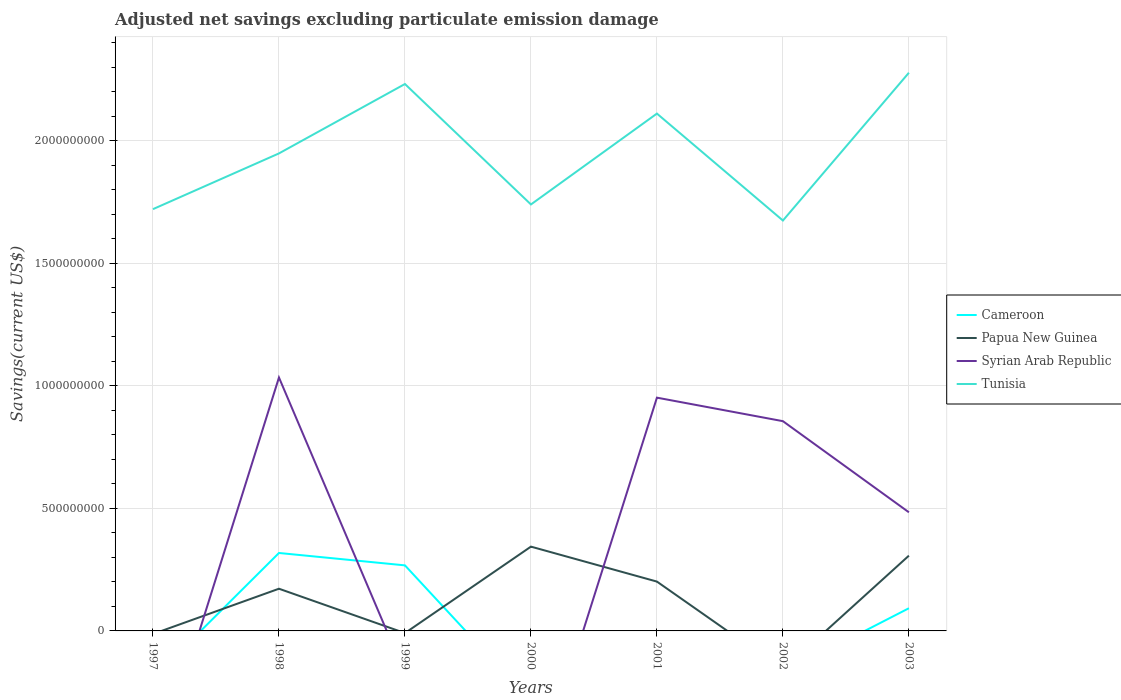Across all years, what is the maximum adjusted net savings in Syrian Arab Republic?
Ensure brevity in your answer.  0. What is the total adjusted net savings in Papua New Guinea in the graph?
Ensure brevity in your answer.  -1.35e+08. What is the difference between the highest and the second highest adjusted net savings in Syrian Arab Republic?
Your answer should be very brief. 1.03e+09. How many lines are there?
Your answer should be compact. 4. Where does the legend appear in the graph?
Offer a terse response. Center right. How are the legend labels stacked?
Offer a terse response. Vertical. What is the title of the graph?
Make the answer very short. Adjusted net savings excluding particulate emission damage. Does "Peru" appear as one of the legend labels in the graph?
Your response must be concise. No. What is the label or title of the Y-axis?
Ensure brevity in your answer.  Savings(current US$). What is the Savings(current US$) of Cameroon in 1997?
Your answer should be compact. 0. What is the Savings(current US$) in Syrian Arab Republic in 1997?
Provide a short and direct response. 0. What is the Savings(current US$) of Tunisia in 1997?
Make the answer very short. 1.72e+09. What is the Savings(current US$) in Cameroon in 1998?
Ensure brevity in your answer.  3.18e+08. What is the Savings(current US$) of Papua New Guinea in 1998?
Give a very brief answer. 1.72e+08. What is the Savings(current US$) in Syrian Arab Republic in 1998?
Offer a terse response. 1.03e+09. What is the Savings(current US$) in Tunisia in 1998?
Offer a terse response. 1.95e+09. What is the Savings(current US$) of Cameroon in 1999?
Your response must be concise. 2.67e+08. What is the Savings(current US$) in Papua New Guinea in 1999?
Offer a very short reply. 0. What is the Savings(current US$) in Syrian Arab Republic in 1999?
Your answer should be very brief. 0. What is the Savings(current US$) of Tunisia in 1999?
Give a very brief answer. 2.23e+09. What is the Savings(current US$) of Papua New Guinea in 2000?
Ensure brevity in your answer.  3.44e+08. What is the Savings(current US$) in Syrian Arab Republic in 2000?
Keep it short and to the point. 0. What is the Savings(current US$) of Tunisia in 2000?
Offer a terse response. 1.74e+09. What is the Savings(current US$) of Papua New Guinea in 2001?
Ensure brevity in your answer.  2.01e+08. What is the Savings(current US$) in Syrian Arab Republic in 2001?
Provide a succinct answer. 9.51e+08. What is the Savings(current US$) of Tunisia in 2001?
Offer a very short reply. 2.11e+09. What is the Savings(current US$) in Cameroon in 2002?
Keep it short and to the point. 0. What is the Savings(current US$) of Papua New Guinea in 2002?
Your answer should be compact. 0. What is the Savings(current US$) of Syrian Arab Republic in 2002?
Keep it short and to the point. 8.56e+08. What is the Savings(current US$) in Tunisia in 2002?
Offer a terse response. 1.67e+09. What is the Savings(current US$) in Cameroon in 2003?
Offer a very short reply. 9.25e+07. What is the Savings(current US$) of Papua New Guinea in 2003?
Offer a very short reply. 3.07e+08. What is the Savings(current US$) in Syrian Arab Republic in 2003?
Provide a short and direct response. 4.84e+08. What is the Savings(current US$) in Tunisia in 2003?
Make the answer very short. 2.28e+09. Across all years, what is the maximum Savings(current US$) of Cameroon?
Make the answer very short. 3.18e+08. Across all years, what is the maximum Savings(current US$) in Papua New Guinea?
Make the answer very short. 3.44e+08. Across all years, what is the maximum Savings(current US$) in Syrian Arab Republic?
Provide a succinct answer. 1.03e+09. Across all years, what is the maximum Savings(current US$) of Tunisia?
Your response must be concise. 2.28e+09. Across all years, what is the minimum Savings(current US$) of Cameroon?
Your answer should be very brief. 0. Across all years, what is the minimum Savings(current US$) in Papua New Guinea?
Your answer should be compact. 0. Across all years, what is the minimum Savings(current US$) in Tunisia?
Your response must be concise. 1.67e+09. What is the total Savings(current US$) of Cameroon in the graph?
Provide a short and direct response. 6.78e+08. What is the total Savings(current US$) of Papua New Guinea in the graph?
Give a very brief answer. 1.02e+09. What is the total Savings(current US$) in Syrian Arab Republic in the graph?
Your answer should be very brief. 3.32e+09. What is the total Savings(current US$) of Tunisia in the graph?
Give a very brief answer. 1.37e+1. What is the difference between the Savings(current US$) in Tunisia in 1997 and that in 1998?
Give a very brief answer. -2.27e+08. What is the difference between the Savings(current US$) in Tunisia in 1997 and that in 1999?
Your answer should be very brief. -5.10e+08. What is the difference between the Savings(current US$) of Tunisia in 1997 and that in 2000?
Give a very brief answer. -1.92e+07. What is the difference between the Savings(current US$) of Tunisia in 1997 and that in 2001?
Ensure brevity in your answer.  -3.90e+08. What is the difference between the Savings(current US$) of Tunisia in 1997 and that in 2002?
Provide a short and direct response. 4.64e+07. What is the difference between the Savings(current US$) in Tunisia in 1997 and that in 2003?
Keep it short and to the point. -5.56e+08. What is the difference between the Savings(current US$) in Cameroon in 1998 and that in 1999?
Provide a short and direct response. 5.05e+07. What is the difference between the Savings(current US$) in Tunisia in 1998 and that in 1999?
Provide a succinct answer. -2.83e+08. What is the difference between the Savings(current US$) in Papua New Guinea in 1998 and that in 2000?
Offer a terse response. -1.72e+08. What is the difference between the Savings(current US$) in Tunisia in 1998 and that in 2000?
Your answer should be compact. 2.08e+08. What is the difference between the Savings(current US$) in Papua New Guinea in 1998 and that in 2001?
Your response must be concise. -2.91e+07. What is the difference between the Savings(current US$) in Syrian Arab Republic in 1998 and that in 2001?
Offer a very short reply. 8.22e+07. What is the difference between the Savings(current US$) in Tunisia in 1998 and that in 2001?
Ensure brevity in your answer.  -1.62e+08. What is the difference between the Savings(current US$) in Syrian Arab Republic in 1998 and that in 2002?
Offer a terse response. 1.78e+08. What is the difference between the Savings(current US$) in Tunisia in 1998 and that in 2002?
Provide a succinct answer. 2.74e+08. What is the difference between the Savings(current US$) of Cameroon in 1998 and that in 2003?
Make the answer very short. 2.25e+08. What is the difference between the Savings(current US$) in Papua New Guinea in 1998 and that in 2003?
Ensure brevity in your answer.  -1.35e+08. What is the difference between the Savings(current US$) in Syrian Arab Republic in 1998 and that in 2003?
Your answer should be compact. 5.50e+08. What is the difference between the Savings(current US$) in Tunisia in 1998 and that in 2003?
Offer a terse response. -3.29e+08. What is the difference between the Savings(current US$) of Tunisia in 1999 and that in 2000?
Your answer should be very brief. 4.91e+08. What is the difference between the Savings(current US$) in Tunisia in 1999 and that in 2001?
Your answer should be very brief. 1.21e+08. What is the difference between the Savings(current US$) of Tunisia in 1999 and that in 2002?
Offer a terse response. 5.57e+08. What is the difference between the Savings(current US$) of Cameroon in 1999 and that in 2003?
Offer a very short reply. 1.75e+08. What is the difference between the Savings(current US$) in Tunisia in 1999 and that in 2003?
Provide a succinct answer. -4.60e+07. What is the difference between the Savings(current US$) of Papua New Guinea in 2000 and that in 2001?
Offer a terse response. 1.43e+08. What is the difference between the Savings(current US$) of Tunisia in 2000 and that in 2001?
Provide a short and direct response. -3.71e+08. What is the difference between the Savings(current US$) in Tunisia in 2000 and that in 2002?
Offer a very short reply. 6.55e+07. What is the difference between the Savings(current US$) in Papua New Guinea in 2000 and that in 2003?
Give a very brief answer. 3.68e+07. What is the difference between the Savings(current US$) in Tunisia in 2000 and that in 2003?
Provide a succinct answer. -5.37e+08. What is the difference between the Savings(current US$) in Syrian Arab Republic in 2001 and that in 2002?
Your answer should be compact. 9.59e+07. What is the difference between the Savings(current US$) in Tunisia in 2001 and that in 2002?
Offer a terse response. 4.36e+08. What is the difference between the Savings(current US$) of Papua New Guinea in 2001 and that in 2003?
Your response must be concise. -1.06e+08. What is the difference between the Savings(current US$) of Syrian Arab Republic in 2001 and that in 2003?
Make the answer very short. 4.68e+08. What is the difference between the Savings(current US$) of Tunisia in 2001 and that in 2003?
Give a very brief answer. -1.67e+08. What is the difference between the Savings(current US$) of Syrian Arab Republic in 2002 and that in 2003?
Offer a very short reply. 3.72e+08. What is the difference between the Savings(current US$) of Tunisia in 2002 and that in 2003?
Ensure brevity in your answer.  -6.03e+08. What is the difference between the Savings(current US$) of Cameroon in 1998 and the Savings(current US$) of Tunisia in 1999?
Your answer should be very brief. -1.91e+09. What is the difference between the Savings(current US$) in Papua New Guinea in 1998 and the Savings(current US$) in Tunisia in 1999?
Give a very brief answer. -2.06e+09. What is the difference between the Savings(current US$) of Syrian Arab Republic in 1998 and the Savings(current US$) of Tunisia in 1999?
Keep it short and to the point. -1.20e+09. What is the difference between the Savings(current US$) in Cameroon in 1998 and the Savings(current US$) in Papua New Guinea in 2000?
Your response must be concise. -2.59e+07. What is the difference between the Savings(current US$) of Cameroon in 1998 and the Savings(current US$) of Tunisia in 2000?
Provide a short and direct response. -1.42e+09. What is the difference between the Savings(current US$) in Papua New Guinea in 1998 and the Savings(current US$) in Tunisia in 2000?
Make the answer very short. -1.57e+09. What is the difference between the Savings(current US$) in Syrian Arab Republic in 1998 and the Savings(current US$) in Tunisia in 2000?
Provide a short and direct response. -7.06e+08. What is the difference between the Savings(current US$) in Cameroon in 1998 and the Savings(current US$) in Papua New Guinea in 2001?
Keep it short and to the point. 1.17e+08. What is the difference between the Savings(current US$) of Cameroon in 1998 and the Savings(current US$) of Syrian Arab Republic in 2001?
Make the answer very short. -6.34e+08. What is the difference between the Savings(current US$) in Cameroon in 1998 and the Savings(current US$) in Tunisia in 2001?
Provide a succinct answer. -1.79e+09. What is the difference between the Savings(current US$) in Papua New Guinea in 1998 and the Savings(current US$) in Syrian Arab Republic in 2001?
Your answer should be very brief. -7.79e+08. What is the difference between the Savings(current US$) of Papua New Guinea in 1998 and the Savings(current US$) of Tunisia in 2001?
Your answer should be very brief. -1.94e+09. What is the difference between the Savings(current US$) of Syrian Arab Republic in 1998 and the Savings(current US$) of Tunisia in 2001?
Your answer should be very brief. -1.08e+09. What is the difference between the Savings(current US$) of Cameroon in 1998 and the Savings(current US$) of Syrian Arab Republic in 2002?
Provide a short and direct response. -5.38e+08. What is the difference between the Savings(current US$) of Cameroon in 1998 and the Savings(current US$) of Tunisia in 2002?
Offer a terse response. -1.36e+09. What is the difference between the Savings(current US$) of Papua New Guinea in 1998 and the Savings(current US$) of Syrian Arab Republic in 2002?
Ensure brevity in your answer.  -6.83e+08. What is the difference between the Savings(current US$) in Papua New Guinea in 1998 and the Savings(current US$) in Tunisia in 2002?
Offer a very short reply. -1.50e+09. What is the difference between the Savings(current US$) of Syrian Arab Republic in 1998 and the Savings(current US$) of Tunisia in 2002?
Your response must be concise. -6.40e+08. What is the difference between the Savings(current US$) of Cameroon in 1998 and the Savings(current US$) of Papua New Guinea in 2003?
Provide a short and direct response. 1.09e+07. What is the difference between the Savings(current US$) in Cameroon in 1998 and the Savings(current US$) in Syrian Arab Republic in 2003?
Ensure brevity in your answer.  -1.66e+08. What is the difference between the Savings(current US$) of Cameroon in 1998 and the Savings(current US$) of Tunisia in 2003?
Offer a very short reply. -1.96e+09. What is the difference between the Savings(current US$) in Papua New Guinea in 1998 and the Savings(current US$) in Syrian Arab Republic in 2003?
Keep it short and to the point. -3.12e+08. What is the difference between the Savings(current US$) in Papua New Guinea in 1998 and the Savings(current US$) in Tunisia in 2003?
Offer a very short reply. -2.10e+09. What is the difference between the Savings(current US$) in Syrian Arab Republic in 1998 and the Savings(current US$) in Tunisia in 2003?
Provide a succinct answer. -1.24e+09. What is the difference between the Savings(current US$) in Cameroon in 1999 and the Savings(current US$) in Papua New Guinea in 2000?
Make the answer very short. -7.64e+07. What is the difference between the Savings(current US$) in Cameroon in 1999 and the Savings(current US$) in Tunisia in 2000?
Give a very brief answer. -1.47e+09. What is the difference between the Savings(current US$) of Cameroon in 1999 and the Savings(current US$) of Papua New Guinea in 2001?
Your answer should be compact. 6.62e+07. What is the difference between the Savings(current US$) of Cameroon in 1999 and the Savings(current US$) of Syrian Arab Republic in 2001?
Provide a succinct answer. -6.84e+08. What is the difference between the Savings(current US$) in Cameroon in 1999 and the Savings(current US$) in Tunisia in 2001?
Keep it short and to the point. -1.84e+09. What is the difference between the Savings(current US$) of Cameroon in 1999 and the Savings(current US$) of Syrian Arab Republic in 2002?
Make the answer very short. -5.88e+08. What is the difference between the Savings(current US$) of Cameroon in 1999 and the Savings(current US$) of Tunisia in 2002?
Provide a succinct answer. -1.41e+09. What is the difference between the Savings(current US$) of Cameroon in 1999 and the Savings(current US$) of Papua New Guinea in 2003?
Provide a short and direct response. -3.96e+07. What is the difference between the Savings(current US$) of Cameroon in 1999 and the Savings(current US$) of Syrian Arab Republic in 2003?
Make the answer very short. -2.16e+08. What is the difference between the Savings(current US$) in Cameroon in 1999 and the Savings(current US$) in Tunisia in 2003?
Your answer should be very brief. -2.01e+09. What is the difference between the Savings(current US$) in Papua New Guinea in 2000 and the Savings(current US$) in Syrian Arab Republic in 2001?
Keep it short and to the point. -6.08e+08. What is the difference between the Savings(current US$) of Papua New Guinea in 2000 and the Savings(current US$) of Tunisia in 2001?
Ensure brevity in your answer.  -1.77e+09. What is the difference between the Savings(current US$) of Papua New Guinea in 2000 and the Savings(current US$) of Syrian Arab Republic in 2002?
Provide a short and direct response. -5.12e+08. What is the difference between the Savings(current US$) in Papua New Guinea in 2000 and the Savings(current US$) in Tunisia in 2002?
Make the answer very short. -1.33e+09. What is the difference between the Savings(current US$) in Papua New Guinea in 2000 and the Savings(current US$) in Syrian Arab Republic in 2003?
Your answer should be compact. -1.40e+08. What is the difference between the Savings(current US$) of Papua New Guinea in 2000 and the Savings(current US$) of Tunisia in 2003?
Keep it short and to the point. -1.93e+09. What is the difference between the Savings(current US$) in Papua New Guinea in 2001 and the Savings(current US$) in Syrian Arab Republic in 2002?
Keep it short and to the point. -6.54e+08. What is the difference between the Savings(current US$) of Papua New Guinea in 2001 and the Savings(current US$) of Tunisia in 2002?
Provide a short and direct response. -1.47e+09. What is the difference between the Savings(current US$) in Syrian Arab Republic in 2001 and the Savings(current US$) in Tunisia in 2002?
Keep it short and to the point. -7.23e+08. What is the difference between the Savings(current US$) of Papua New Guinea in 2001 and the Savings(current US$) of Syrian Arab Republic in 2003?
Your answer should be compact. -2.83e+08. What is the difference between the Savings(current US$) in Papua New Guinea in 2001 and the Savings(current US$) in Tunisia in 2003?
Your response must be concise. -2.08e+09. What is the difference between the Savings(current US$) in Syrian Arab Republic in 2001 and the Savings(current US$) in Tunisia in 2003?
Make the answer very short. -1.33e+09. What is the difference between the Savings(current US$) of Syrian Arab Republic in 2002 and the Savings(current US$) of Tunisia in 2003?
Provide a short and direct response. -1.42e+09. What is the average Savings(current US$) of Cameroon per year?
Provide a succinct answer. 9.68e+07. What is the average Savings(current US$) in Papua New Guinea per year?
Provide a succinct answer. 1.46e+08. What is the average Savings(current US$) in Syrian Arab Republic per year?
Your answer should be compact. 4.75e+08. What is the average Savings(current US$) in Tunisia per year?
Your response must be concise. 1.96e+09. In the year 1998, what is the difference between the Savings(current US$) in Cameroon and Savings(current US$) in Papua New Guinea?
Keep it short and to the point. 1.46e+08. In the year 1998, what is the difference between the Savings(current US$) of Cameroon and Savings(current US$) of Syrian Arab Republic?
Keep it short and to the point. -7.16e+08. In the year 1998, what is the difference between the Savings(current US$) of Cameroon and Savings(current US$) of Tunisia?
Provide a succinct answer. -1.63e+09. In the year 1998, what is the difference between the Savings(current US$) of Papua New Guinea and Savings(current US$) of Syrian Arab Republic?
Your answer should be compact. -8.62e+08. In the year 1998, what is the difference between the Savings(current US$) in Papua New Guinea and Savings(current US$) in Tunisia?
Provide a succinct answer. -1.78e+09. In the year 1998, what is the difference between the Savings(current US$) of Syrian Arab Republic and Savings(current US$) of Tunisia?
Offer a very short reply. -9.14e+08. In the year 1999, what is the difference between the Savings(current US$) of Cameroon and Savings(current US$) of Tunisia?
Your answer should be compact. -1.96e+09. In the year 2000, what is the difference between the Savings(current US$) of Papua New Guinea and Savings(current US$) of Tunisia?
Your response must be concise. -1.40e+09. In the year 2001, what is the difference between the Savings(current US$) in Papua New Guinea and Savings(current US$) in Syrian Arab Republic?
Keep it short and to the point. -7.50e+08. In the year 2001, what is the difference between the Savings(current US$) of Papua New Guinea and Savings(current US$) of Tunisia?
Ensure brevity in your answer.  -1.91e+09. In the year 2001, what is the difference between the Savings(current US$) in Syrian Arab Republic and Savings(current US$) in Tunisia?
Keep it short and to the point. -1.16e+09. In the year 2002, what is the difference between the Savings(current US$) in Syrian Arab Republic and Savings(current US$) in Tunisia?
Keep it short and to the point. -8.18e+08. In the year 2003, what is the difference between the Savings(current US$) in Cameroon and Savings(current US$) in Papua New Guinea?
Provide a short and direct response. -2.14e+08. In the year 2003, what is the difference between the Savings(current US$) in Cameroon and Savings(current US$) in Syrian Arab Republic?
Ensure brevity in your answer.  -3.91e+08. In the year 2003, what is the difference between the Savings(current US$) in Cameroon and Savings(current US$) in Tunisia?
Provide a short and direct response. -2.18e+09. In the year 2003, what is the difference between the Savings(current US$) in Papua New Guinea and Savings(current US$) in Syrian Arab Republic?
Ensure brevity in your answer.  -1.77e+08. In the year 2003, what is the difference between the Savings(current US$) of Papua New Guinea and Savings(current US$) of Tunisia?
Provide a succinct answer. -1.97e+09. In the year 2003, what is the difference between the Savings(current US$) in Syrian Arab Republic and Savings(current US$) in Tunisia?
Your response must be concise. -1.79e+09. What is the ratio of the Savings(current US$) in Tunisia in 1997 to that in 1998?
Your answer should be compact. 0.88. What is the ratio of the Savings(current US$) in Tunisia in 1997 to that in 1999?
Keep it short and to the point. 0.77. What is the ratio of the Savings(current US$) in Tunisia in 1997 to that in 2000?
Provide a succinct answer. 0.99. What is the ratio of the Savings(current US$) in Tunisia in 1997 to that in 2001?
Ensure brevity in your answer.  0.82. What is the ratio of the Savings(current US$) in Tunisia in 1997 to that in 2002?
Keep it short and to the point. 1.03. What is the ratio of the Savings(current US$) of Tunisia in 1997 to that in 2003?
Keep it short and to the point. 0.76. What is the ratio of the Savings(current US$) of Cameroon in 1998 to that in 1999?
Keep it short and to the point. 1.19. What is the ratio of the Savings(current US$) of Tunisia in 1998 to that in 1999?
Ensure brevity in your answer.  0.87. What is the ratio of the Savings(current US$) in Papua New Guinea in 1998 to that in 2000?
Offer a terse response. 0.5. What is the ratio of the Savings(current US$) of Tunisia in 1998 to that in 2000?
Provide a succinct answer. 1.12. What is the ratio of the Savings(current US$) in Papua New Guinea in 1998 to that in 2001?
Give a very brief answer. 0.86. What is the ratio of the Savings(current US$) in Syrian Arab Republic in 1998 to that in 2001?
Offer a very short reply. 1.09. What is the ratio of the Savings(current US$) of Tunisia in 1998 to that in 2001?
Your answer should be very brief. 0.92. What is the ratio of the Savings(current US$) in Syrian Arab Republic in 1998 to that in 2002?
Your answer should be compact. 1.21. What is the ratio of the Savings(current US$) in Tunisia in 1998 to that in 2002?
Your answer should be compact. 1.16. What is the ratio of the Savings(current US$) of Cameroon in 1998 to that in 2003?
Your answer should be very brief. 3.44. What is the ratio of the Savings(current US$) of Papua New Guinea in 1998 to that in 2003?
Give a very brief answer. 0.56. What is the ratio of the Savings(current US$) in Syrian Arab Republic in 1998 to that in 2003?
Give a very brief answer. 2.14. What is the ratio of the Savings(current US$) of Tunisia in 1998 to that in 2003?
Offer a terse response. 0.86. What is the ratio of the Savings(current US$) in Tunisia in 1999 to that in 2000?
Keep it short and to the point. 1.28. What is the ratio of the Savings(current US$) in Tunisia in 1999 to that in 2001?
Provide a succinct answer. 1.06. What is the ratio of the Savings(current US$) of Tunisia in 1999 to that in 2002?
Offer a very short reply. 1.33. What is the ratio of the Savings(current US$) in Cameroon in 1999 to that in 2003?
Your answer should be very brief. 2.89. What is the ratio of the Savings(current US$) of Tunisia in 1999 to that in 2003?
Provide a succinct answer. 0.98. What is the ratio of the Savings(current US$) of Papua New Guinea in 2000 to that in 2001?
Ensure brevity in your answer.  1.71. What is the ratio of the Savings(current US$) in Tunisia in 2000 to that in 2001?
Keep it short and to the point. 0.82. What is the ratio of the Savings(current US$) in Tunisia in 2000 to that in 2002?
Your response must be concise. 1.04. What is the ratio of the Savings(current US$) in Papua New Guinea in 2000 to that in 2003?
Your answer should be very brief. 1.12. What is the ratio of the Savings(current US$) in Tunisia in 2000 to that in 2003?
Provide a short and direct response. 0.76. What is the ratio of the Savings(current US$) of Syrian Arab Republic in 2001 to that in 2002?
Provide a succinct answer. 1.11. What is the ratio of the Savings(current US$) of Tunisia in 2001 to that in 2002?
Your answer should be very brief. 1.26. What is the ratio of the Savings(current US$) in Papua New Guinea in 2001 to that in 2003?
Your response must be concise. 0.66. What is the ratio of the Savings(current US$) in Syrian Arab Republic in 2001 to that in 2003?
Offer a terse response. 1.97. What is the ratio of the Savings(current US$) in Tunisia in 2001 to that in 2003?
Your answer should be very brief. 0.93. What is the ratio of the Savings(current US$) of Syrian Arab Republic in 2002 to that in 2003?
Offer a terse response. 1.77. What is the ratio of the Savings(current US$) in Tunisia in 2002 to that in 2003?
Provide a short and direct response. 0.74. What is the difference between the highest and the second highest Savings(current US$) of Cameroon?
Give a very brief answer. 5.05e+07. What is the difference between the highest and the second highest Savings(current US$) of Papua New Guinea?
Ensure brevity in your answer.  3.68e+07. What is the difference between the highest and the second highest Savings(current US$) of Syrian Arab Republic?
Your answer should be compact. 8.22e+07. What is the difference between the highest and the second highest Savings(current US$) of Tunisia?
Your answer should be very brief. 4.60e+07. What is the difference between the highest and the lowest Savings(current US$) of Cameroon?
Ensure brevity in your answer.  3.18e+08. What is the difference between the highest and the lowest Savings(current US$) in Papua New Guinea?
Your answer should be very brief. 3.44e+08. What is the difference between the highest and the lowest Savings(current US$) in Syrian Arab Republic?
Your answer should be compact. 1.03e+09. What is the difference between the highest and the lowest Savings(current US$) of Tunisia?
Ensure brevity in your answer.  6.03e+08. 